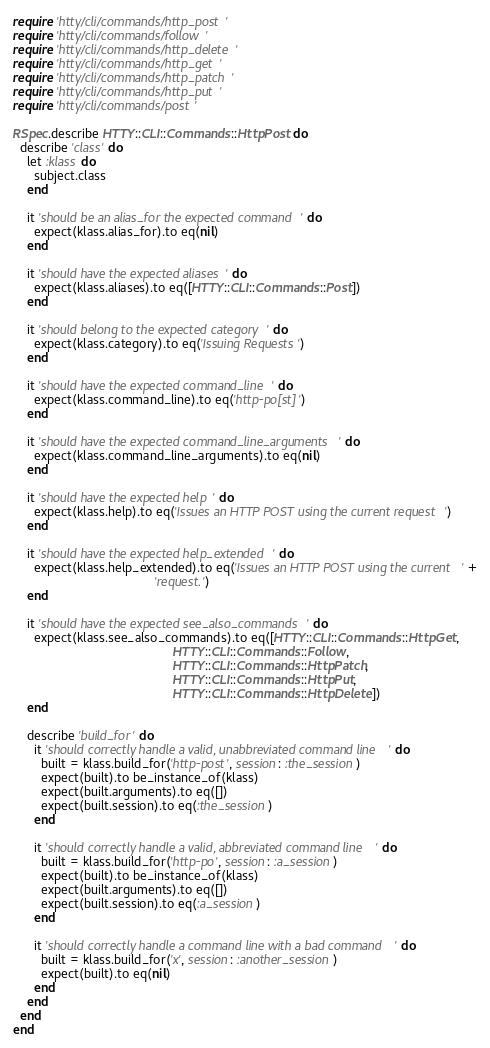Convert code to text. <code><loc_0><loc_0><loc_500><loc_500><_Ruby_>require 'htty/cli/commands/http_post'
require 'htty/cli/commands/follow'
require 'htty/cli/commands/http_delete'
require 'htty/cli/commands/http_get'
require 'htty/cli/commands/http_patch'
require 'htty/cli/commands/http_put'
require 'htty/cli/commands/post'

RSpec.describe HTTY::CLI::Commands::HttpPost do
  describe 'class' do
    let :klass do
      subject.class
    end

    it 'should be an alias_for the expected command' do
      expect(klass.alias_for).to eq(nil)
    end

    it 'should have the expected aliases' do
      expect(klass.aliases).to eq([HTTY::CLI::Commands::Post])
    end

    it 'should belong to the expected category' do
      expect(klass.category).to eq('Issuing Requests')
    end

    it 'should have the expected command_line' do
      expect(klass.command_line).to eq('http-po[st]')
    end

    it 'should have the expected command_line_arguments' do
      expect(klass.command_line_arguments).to eq(nil)
    end

    it 'should have the expected help' do
      expect(klass.help).to eq('Issues an HTTP POST using the current request')
    end

    it 'should have the expected help_extended' do
      expect(klass.help_extended).to eq('Issues an HTTP POST using the current ' +
                                        'request.')
    end

    it 'should have the expected see_also_commands' do
      expect(klass.see_also_commands).to eq([HTTY::CLI::Commands::HttpGet,
                                             HTTY::CLI::Commands::Follow,
                                             HTTY::CLI::Commands::HttpPatch,
                                             HTTY::CLI::Commands::HttpPut,
                                             HTTY::CLI::Commands::HttpDelete])
    end

    describe 'build_for' do
      it 'should correctly handle a valid, unabbreviated command line' do
        built = klass.build_for('http-post', session: :the_session)
        expect(built).to be_instance_of(klass)
        expect(built.arguments).to eq([])
        expect(built.session).to eq(:the_session)
      end

      it 'should correctly handle a valid, abbreviated command line' do
        built = klass.build_for('http-po', session: :a_session)
        expect(built).to be_instance_of(klass)
        expect(built.arguments).to eq([])
        expect(built.session).to eq(:a_session)
      end

      it 'should correctly handle a command line with a bad command' do
        built = klass.build_for('x', session: :another_session)
        expect(built).to eq(nil)
      end
    end
  end
end
</code> 